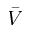<formula> <loc_0><loc_0><loc_500><loc_500>\bar { V }</formula> 